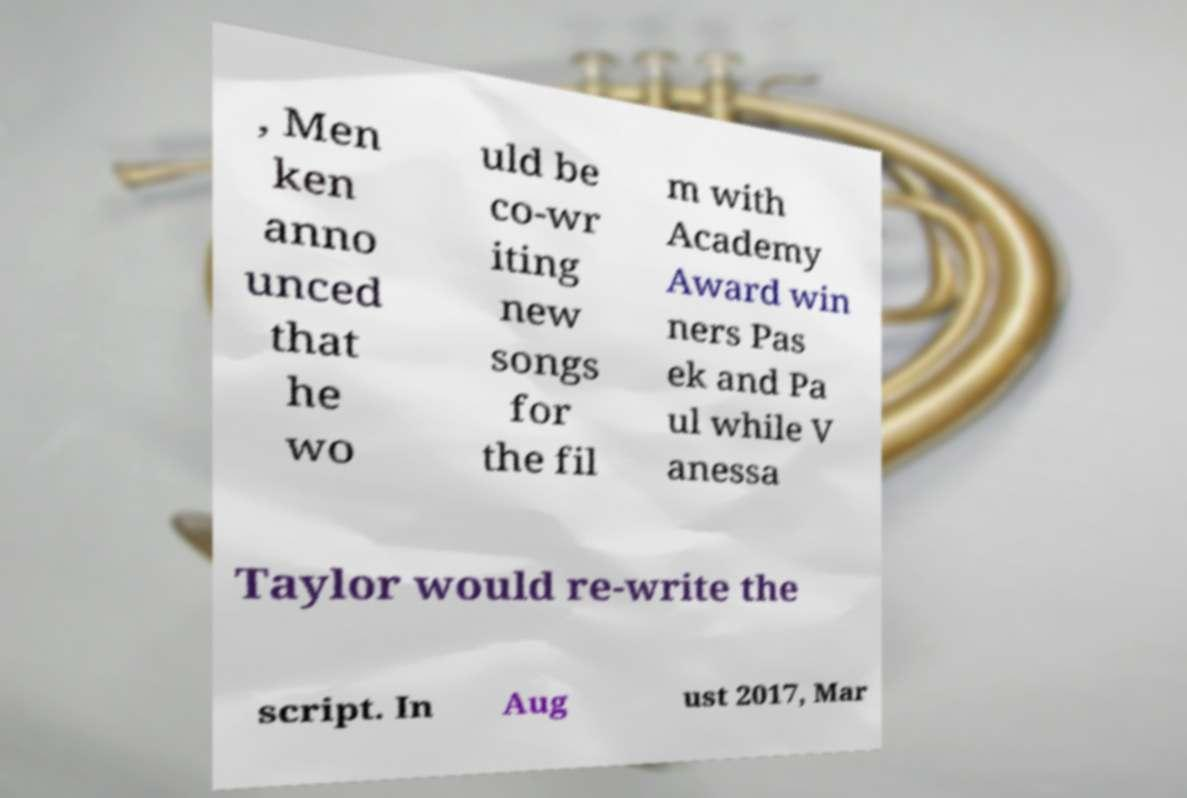Please read and relay the text visible in this image. What does it say? , Men ken anno unced that he wo uld be co-wr iting new songs for the fil m with Academy Award win ners Pas ek and Pa ul while V anessa Taylor would re-write the script. In Aug ust 2017, Mar 